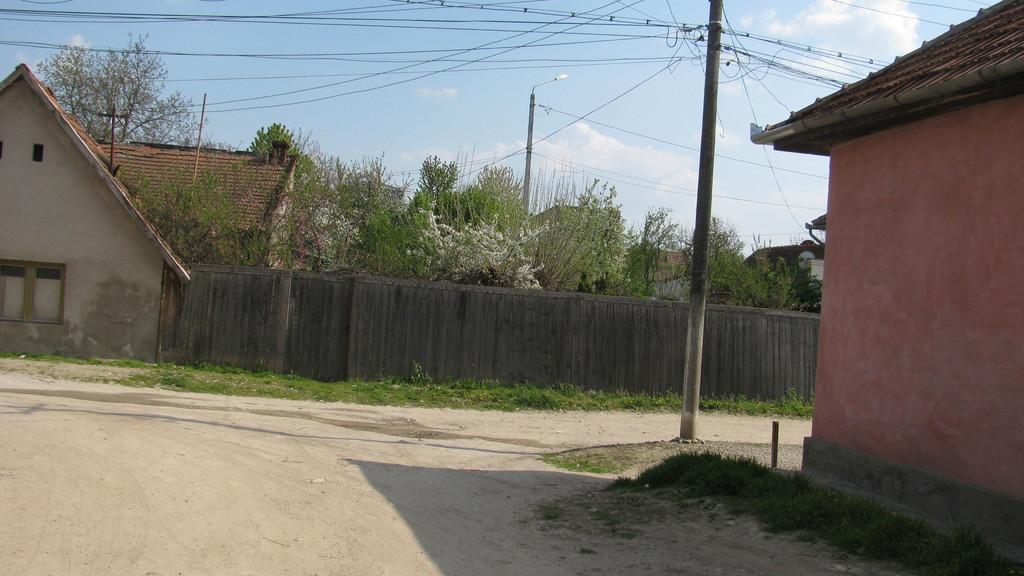Describe this image in one or two sentences. In this image there are buildings with trees and there is a fencing wall, on the right side of the image there is a house and there are few utility poles and street lights. In the background there is the sky. 